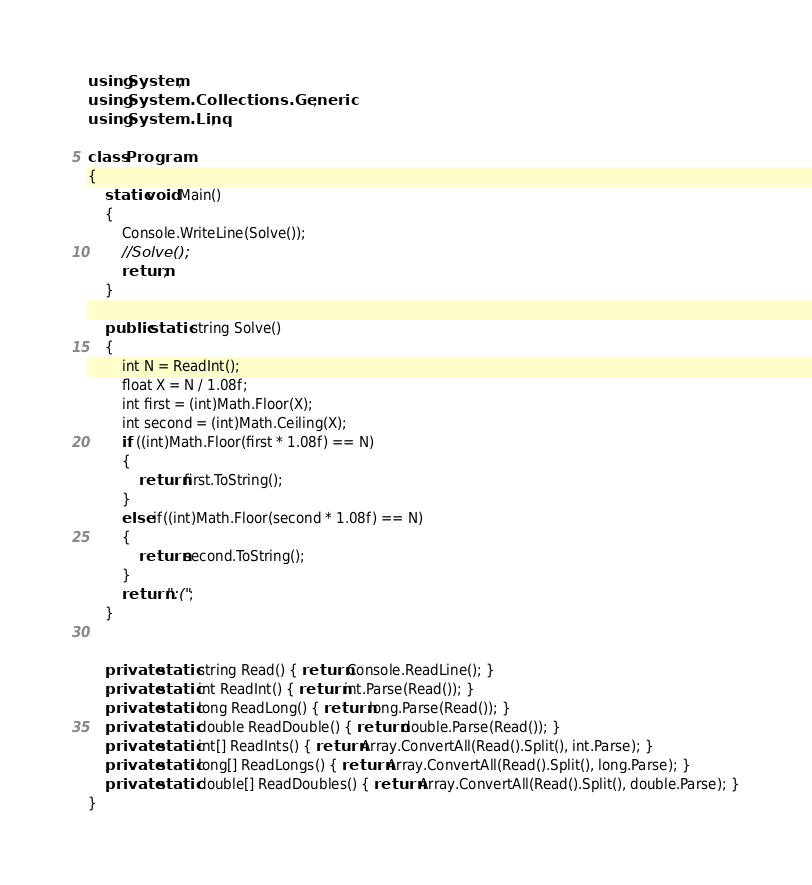Convert code to text. <code><loc_0><loc_0><loc_500><loc_500><_C#_>using System;
using System.Collections.Generic;
using System.Linq;

class Program
{
    static void Main()
    {
        Console.WriteLine(Solve());
        //Solve();
        return;
    }

    public static string Solve()
    {
        int N = ReadInt();
        float X = N / 1.08f;
        int first = (int)Math.Floor(X);
        int second = (int)Math.Ceiling(X);
        if ((int)Math.Floor(first * 1.08f) == N)
        {
            return first.ToString();
        }
        else if((int)Math.Floor(second * 1.08f) == N)
        {
            return second.ToString();
        }
        return ":(";
    }


    private static string Read() { return Console.ReadLine(); }
    private static int ReadInt() { return int.Parse(Read()); }
    private static long ReadLong() { return long.Parse(Read()); }
    private static double ReadDouble() { return double.Parse(Read()); }
    private static int[] ReadInts() { return Array.ConvertAll(Read().Split(), int.Parse); }
    private static long[] ReadLongs() { return Array.ConvertAll(Read().Split(), long.Parse); }
    private static double[] ReadDoubles() { return Array.ConvertAll(Read().Split(), double.Parse); }
}
</code> 